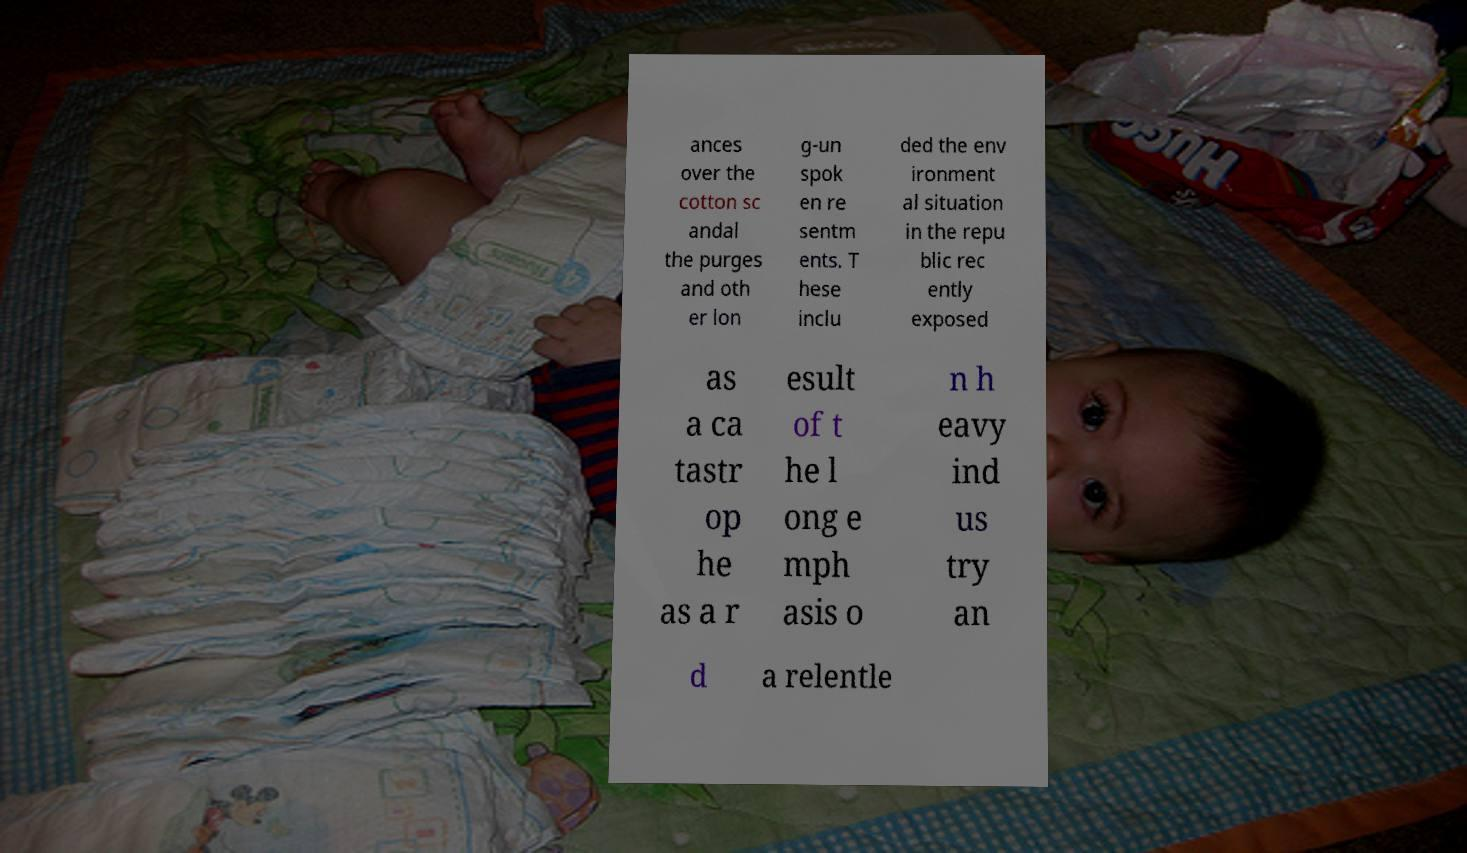Could you extract and type out the text from this image? ances over the cotton sc andal the purges and oth er lon g-un spok en re sentm ents. T hese inclu ded the env ironment al situation in the repu blic rec ently exposed as a ca tastr op he as a r esult of t he l ong e mph asis o n h eavy ind us try an d a relentle 